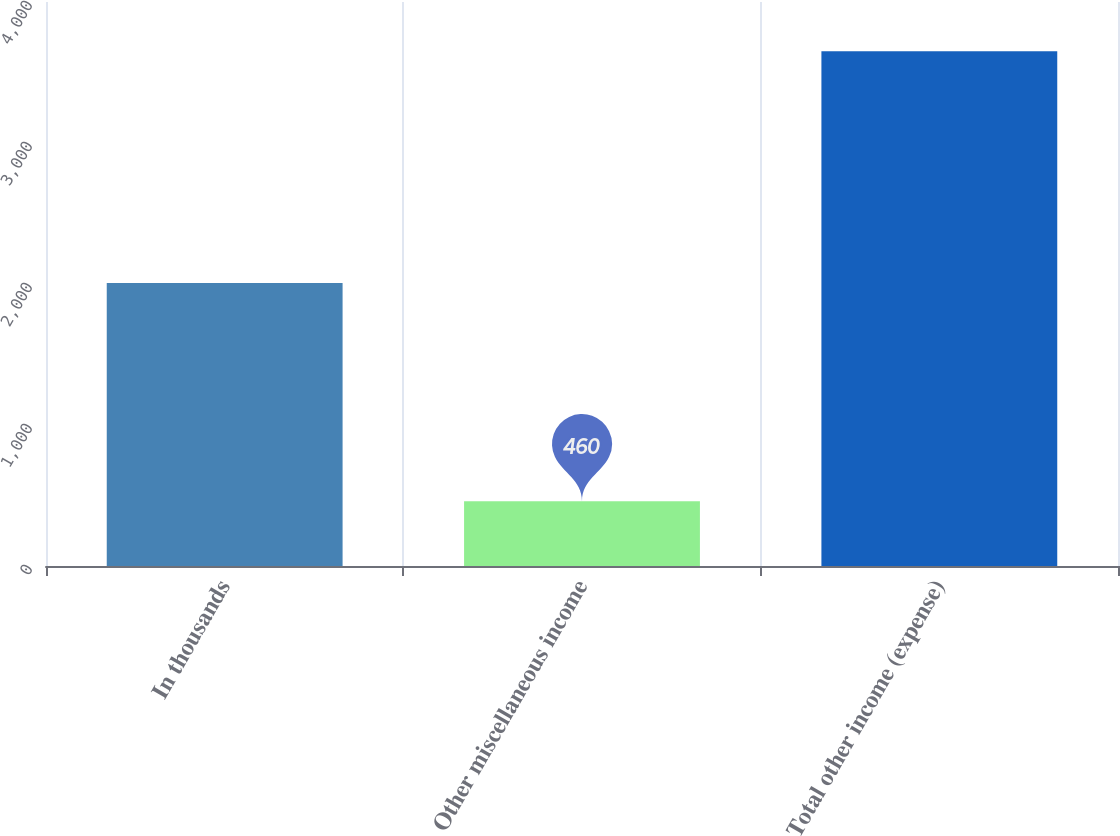Convert chart to OTSL. <chart><loc_0><loc_0><loc_500><loc_500><bar_chart><fcel>In thousands<fcel>Other miscellaneous income<fcel>Total other income (expense)<nl><fcel>2007<fcel>460<fcel>3650<nl></chart> 